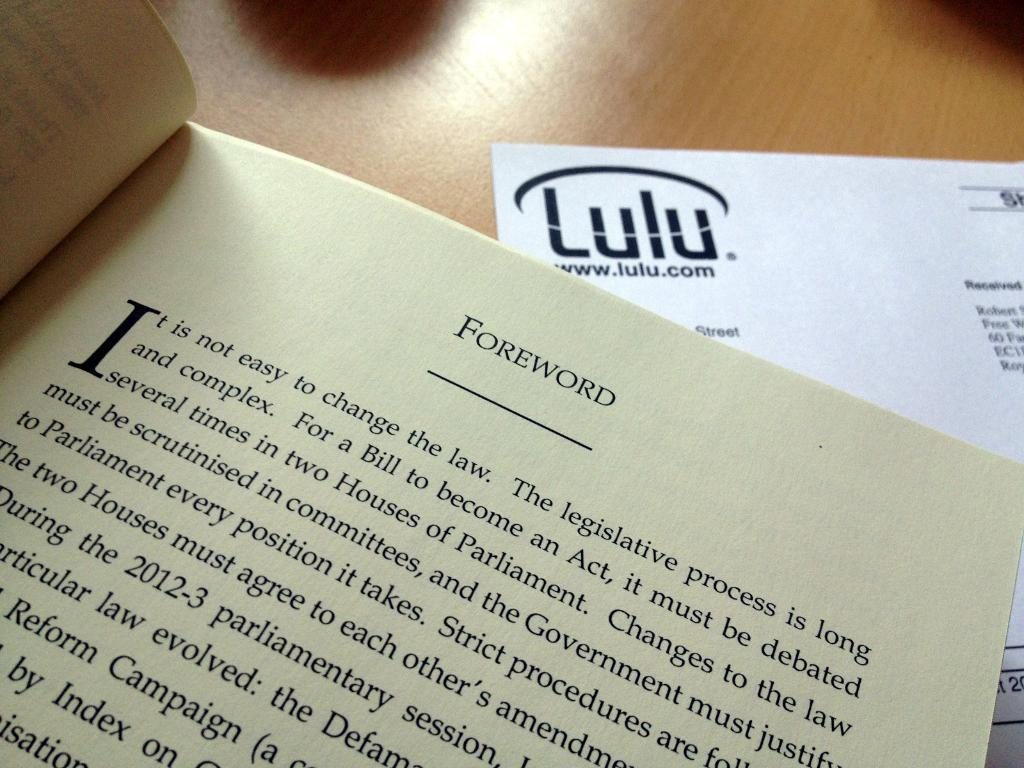<image>
Present a compact description of the photo's key features. A paper with a logo for lulu.com sits under a book. 